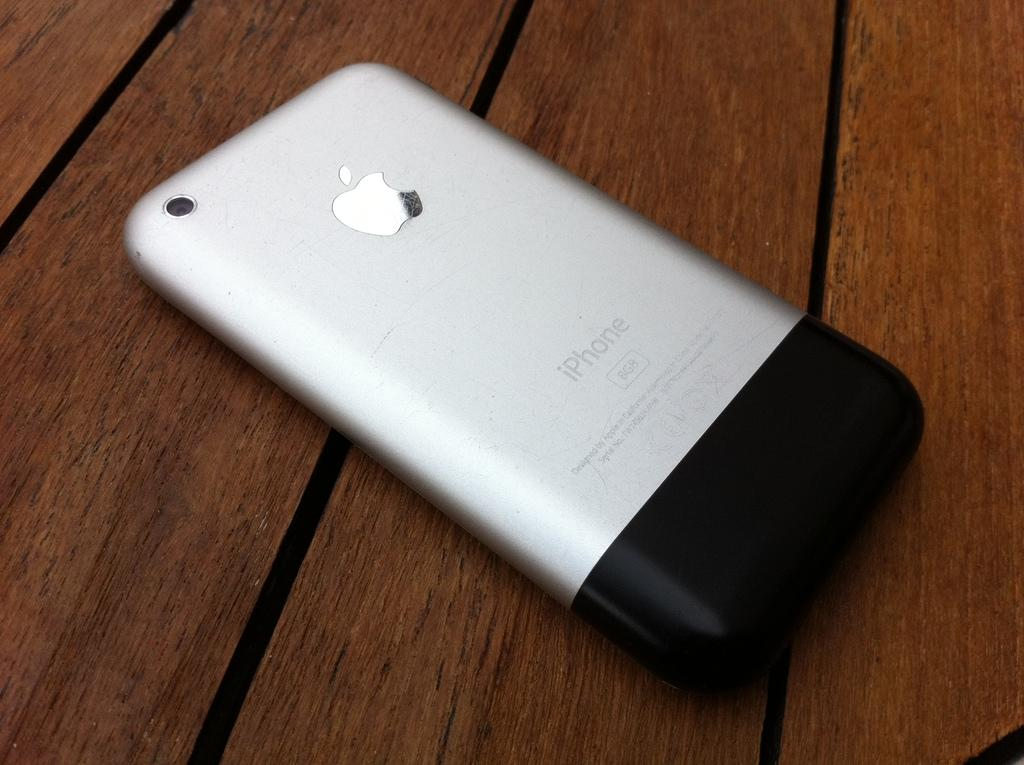<image>
Write a terse but informative summary of the picture. The iphone is laying upside down on the wood table. 